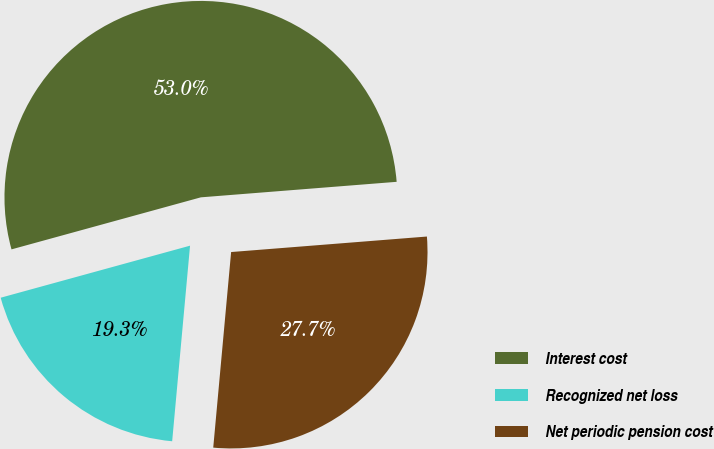<chart> <loc_0><loc_0><loc_500><loc_500><pie_chart><fcel>Interest cost<fcel>Recognized net loss<fcel>Net periodic pension cost<nl><fcel>53.01%<fcel>19.28%<fcel>27.71%<nl></chart> 